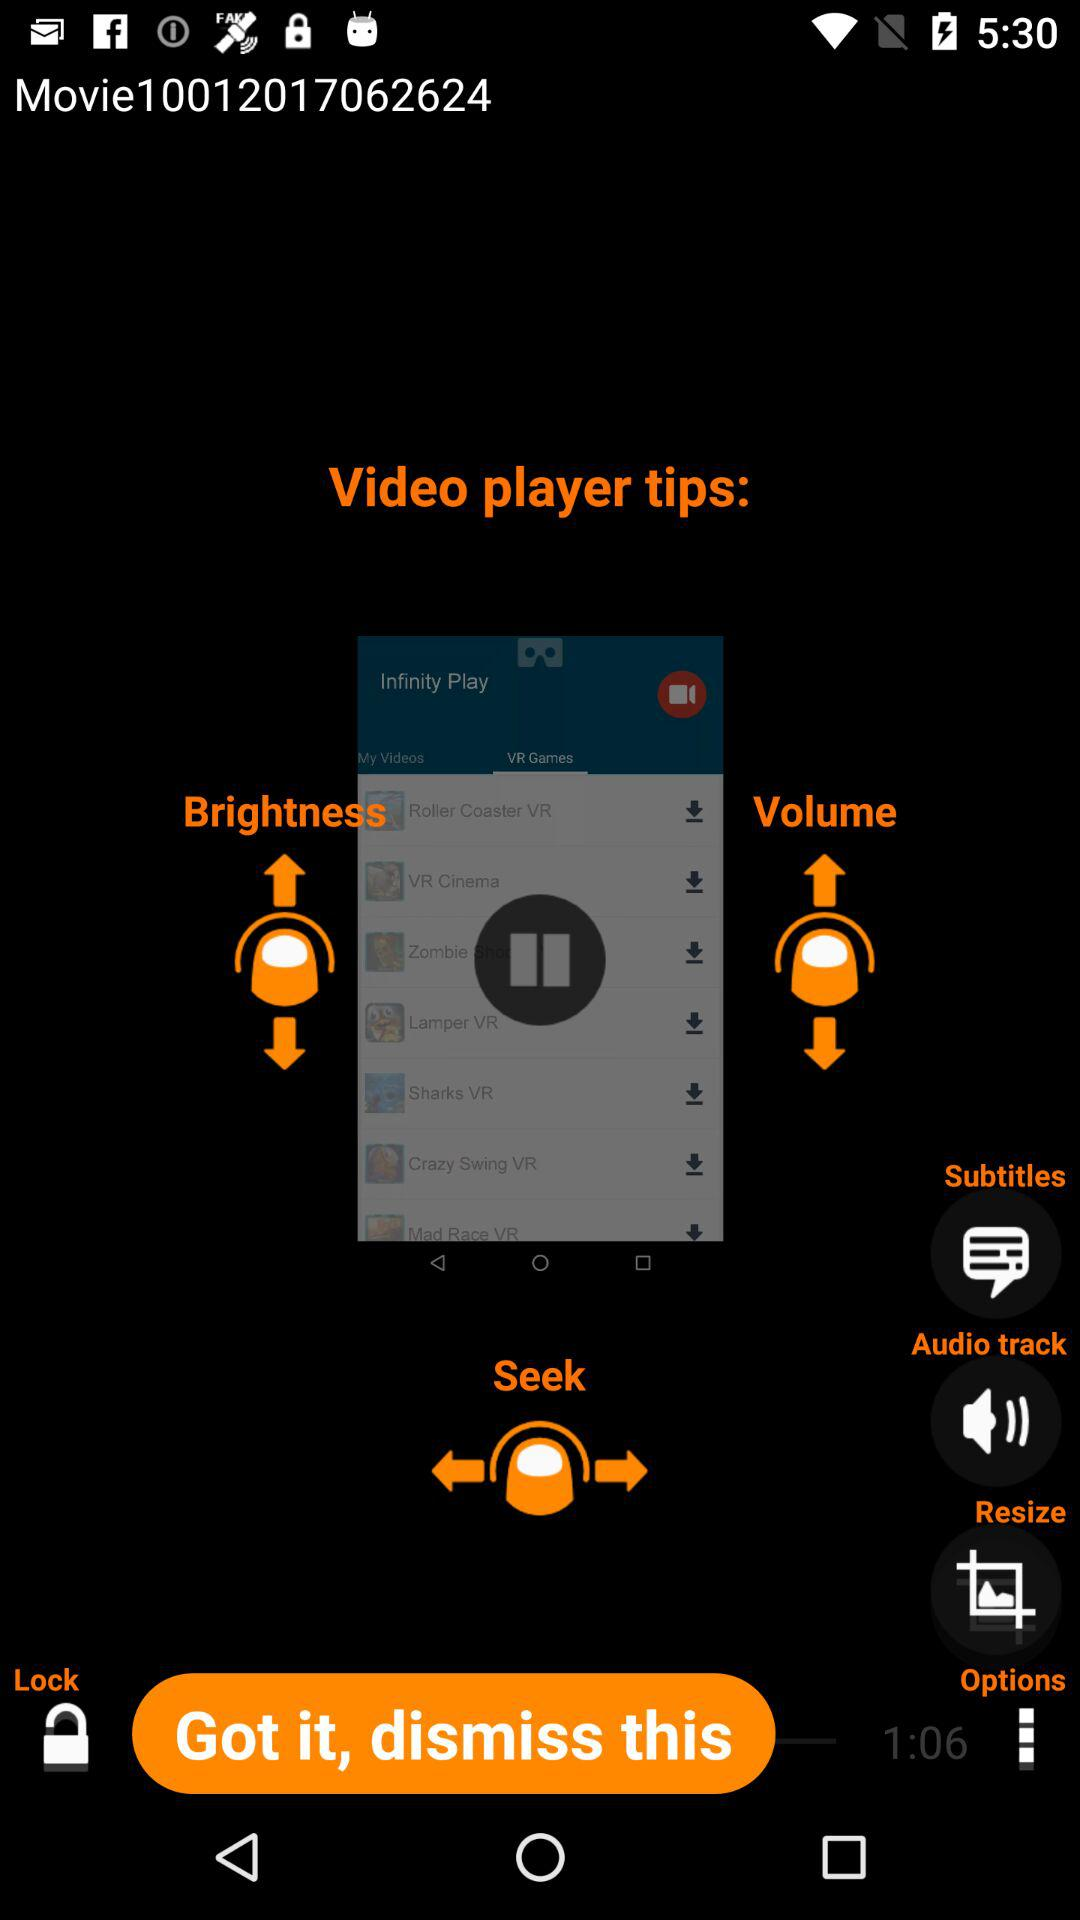What is the number of the movie? The number of the movie is 10012017062624. 